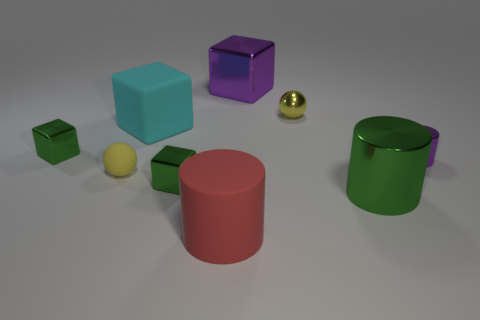Add 1 spheres. How many objects exist? 10 Subtract all cyan cubes. How many cubes are left? 3 Subtract all shiny cylinders. How many cylinders are left? 1 Subtract all cubes. How many objects are left? 5 Subtract 1 balls. How many balls are left? 1 Subtract all blue spheres. How many green blocks are left? 2 Subtract all big purple metallic cubes. Subtract all small blue spheres. How many objects are left? 8 Add 7 small cubes. How many small cubes are left? 9 Add 2 large cyan matte cylinders. How many large cyan matte cylinders exist? 2 Subtract 1 yellow spheres. How many objects are left? 8 